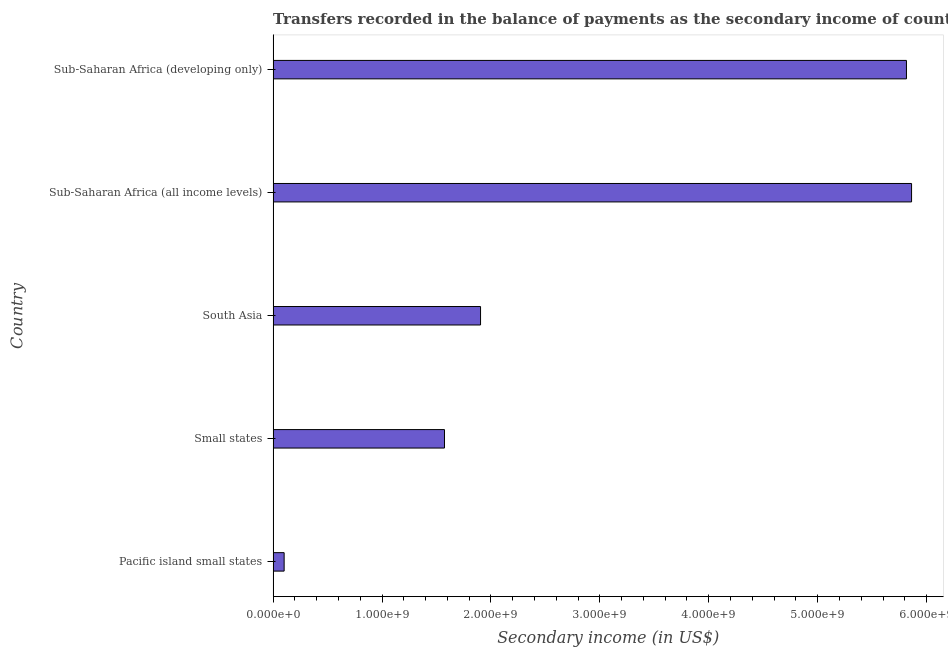Does the graph contain any zero values?
Keep it short and to the point. No. What is the title of the graph?
Keep it short and to the point. Transfers recorded in the balance of payments as the secondary income of countries in the year 2007. What is the label or title of the X-axis?
Make the answer very short. Secondary income (in US$). What is the label or title of the Y-axis?
Your response must be concise. Country. What is the amount of secondary income in Pacific island small states?
Ensure brevity in your answer.  1.01e+08. Across all countries, what is the maximum amount of secondary income?
Keep it short and to the point. 5.86e+09. Across all countries, what is the minimum amount of secondary income?
Give a very brief answer. 1.01e+08. In which country was the amount of secondary income maximum?
Offer a terse response. Sub-Saharan Africa (all income levels). In which country was the amount of secondary income minimum?
Ensure brevity in your answer.  Pacific island small states. What is the sum of the amount of secondary income?
Offer a terse response. 1.53e+1. What is the difference between the amount of secondary income in Sub-Saharan Africa (all income levels) and Sub-Saharan Africa (developing only)?
Your response must be concise. 4.69e+07. What is the average amount of secondary income per country?
Provide a short and direct response. 3.05e+09. What is the median amount of secondary income?
Give a very brief answer. 1.90e+09. In how many countries, is the amount of secondary income greater than 5800000000 US$?
Your response must be concise. 2. What is the ratio of the amount of secondary income in South Asia to that in Sub-Saharan Africa (all income levels)?
Provide a succinct answer. 0.33. What is the difference between the highest and the second highest amount of secondary income?
Your response must be concise. 4.69e+07. Is the sum of the amount of secondary income in South Asia and Sub-Saharan Africa (developing only) greater than the maximum amount of secondary income across all countries?
Ensure brevity in your answer.  Yes. What is the difference between the highest and the lowest amount of secondary income?
Your response must be concise. 5.76e+09. Are all the bars in the graph horizontal?
Ensure brevity in your answer.  Yes. How many countries are there in the graph?
Your response must be concise. 5. What is the difference between two consecutive major ticks on the X-axis?
Offer a very short reply. 1.00e+09. Are the values on the major ticks of X-axis written in scientific E-notation?
Offer a terse response. Yes. What is the Secondary income (in US$) in Pacific island small states?
Your answer should be compact. 1.01e+08. What is the Secondary income (in US$) of Small states?
Your answer should be compact. 1.57e+09. What is the Secondary income (in US$) of South Asia?
Provide a succinct answer. 1.90e+09. What is the Secondary income (in US$) in Sub-Saharan Africa (all income levels)?
Provide a succinct answer. 5.86e+09. What is the Secondary income (in US$) in Sub-Saharan Africa (developing only)?
Offer a terse response. 5.82e+09. What is the difference between the Secondary income (in US$) in Pacific island small states and Small states?
Offer a very short reply. -1.47e+09. What is the difference between the Secondary income (in US$) in Pacific island small states and South Asia?
Provide a short and direct response. -1.80e+09. What is the difference between the Secondary income (in US$) in Pacific island small states and Sub-Saharan Africa (all income levels)?
Provide a short and direct response. -5.76e+09. What is the difference between the Secondary income (in US$) in Pacific island small states and Sub-Saharan Africa (developing only)?
Keep it short and to the point. -5.71e+09. What is the difference between the Secondary income (in US$) in Small states and South Asia?
Your answer should be compact. -3.31e+08. What is the difference between the Secondary income (in US$) in Small states and Sub-Saharan Africa (all income levels)?
Offer a terse response. -4.29e+09. What is the difference between the Secondary income (in US$) in Small states and Sub-Saharan Africa (developing only)?
Provide a short and direct response. -4.24e+09. What is the difference between the Secondary income (in US$) in South Asia and Sub-Saharan Africa (all income levels)?
Your response must be concise. -3.96e+09. What is the difference between the Secondary income (in US$) in South Asia and Sub-Saharan Africa (developing only)?
Provide a short and direct response. -3.91e+09. What is the difference between the Secondary income (in US$) in Sub-Saharan Africa (all income levels) and Sub-Saharan Africa (developing only)?
Give a very brief answer. 4.69e+07. What is the ratio of the Secondary income (in US$) in Pacific island small states to that in Small states?
Keep it short and to the point. 0.06. What is the ratio of the Secondary income (in US$) in Pacific island small states to that in South Asia?
Your answer should be compact. 0.05. What is the ratio of the Secondary income (in US$) in Pacific island small states to that in Sub-Saharan Africa (all income levels)?
Your answer should be compact. 0.02. What is the ratio of the Secondary income (in US$) in Pacific island small states to that in Sub-Saharan Africa (developing only)?
Keep it short and to the point. 0.02. What is the ratio of the Secondary income (in US$) in Small states to that in South Asia?
Your response must be concise. 0.83. What is the ratio of the Secondary income (in US$) in Small states to that in Sub-Saharan Africa (all income levels)?
Make the answer very short. 0.27. What is the ratio of the Secondary income (in US$) in Small states to that in Sub-Saharan Africa (developing only)?
Offer a very short reply. 0.27. What is the ratio of the Secondary income (in US$) in South Asia to that in Sub-Saharan Africa (all income levels)?
Your answer should be very brief. 0.33. What is the ratio of the Secondary income (in US$) in South Asia to that in Sub-Saharan Africa (developing only)?
Your response must be concise. 0.33. What is the ratio of the Secondary income (in US$) in Sub-Saharan Africa (all income levels) to that in Sub-Saharan Africa (developing only)?
Your answer should be compact. 1.01. 